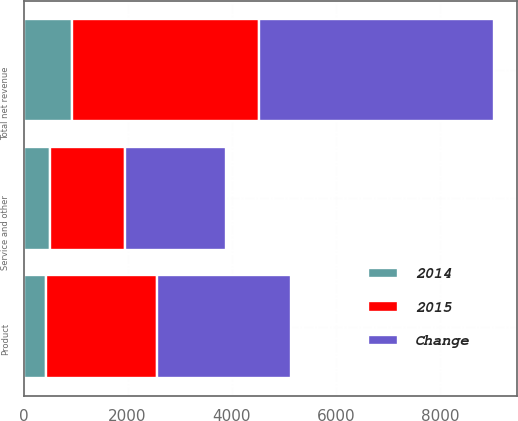<chart> <loc_0><loc_0><loc_500><loc_500><stacked_bar_chart><ecel><fcel>Product<fcel>Service and other<fcel>Total net revenue<nl><fcel>Change<fcel>2568<fcel>1947<fcel>4515<nl><fcel>2015<fcel>2134<fcel>1441<fcel>3575<nl><fcel>2014<fcel>434<fcel>506<fcel>940<nl></chart> 